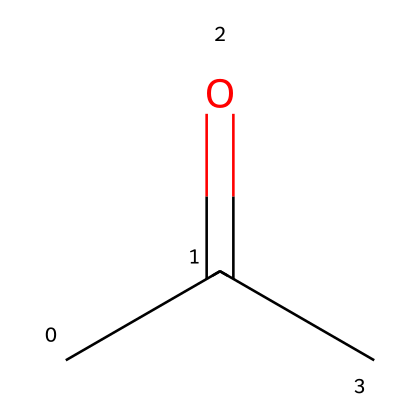What is the molecular formula of acetone? The SMILES representation shows that there are three carbon atoms (C), six hydrogen atoms (H), and one oxygen atom (O) present, which gives the molecular formula C3H6O.
Answer: C3H6O How many carbon atoms are in the structure? The SMILES notation indicates three carbon atoms are present in the structure (CC(=O)C).
Answer: 3 What type of functional group is present in acetone? In the structure CC(=O)C, the presence of the carbonyl group (C=O) indicates that acetone contains a ketone functional group.
Answer: ketone What is the total number of hydrogen atoms in acetone? By analyzing the SMILES structure, it shows that four hydrogen atoms are directly bonded to the carbon atoms and two are accounted for indirectly due to the carbonyl group, totaling six hydrogen atoms.
Answer: 6 Is acetone a polar solvent? Acetone has a polar structure due to the presence of a carbonyl group (C=O), which makes it capable of engaging in dipole-dipole interactions, indicating that it is a polar solvent.
Answer: yes Why can acetone dissolve oils and fats? The presence of both polar (from the carbonyl) and nonpolar (from the carbon chain) characteristics in acetone allows it to interact with a wide range of substances, including oils and fats, thereby acting as a good solvent.
Answer: due to its polar and nonpolar characteristics 